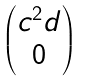<formula> <loc_0><loc_0><loc_500><loc_500>\begin{pmatrix} c ^ { 2 } d \\ 0 \end{pmatrix}</formula> 